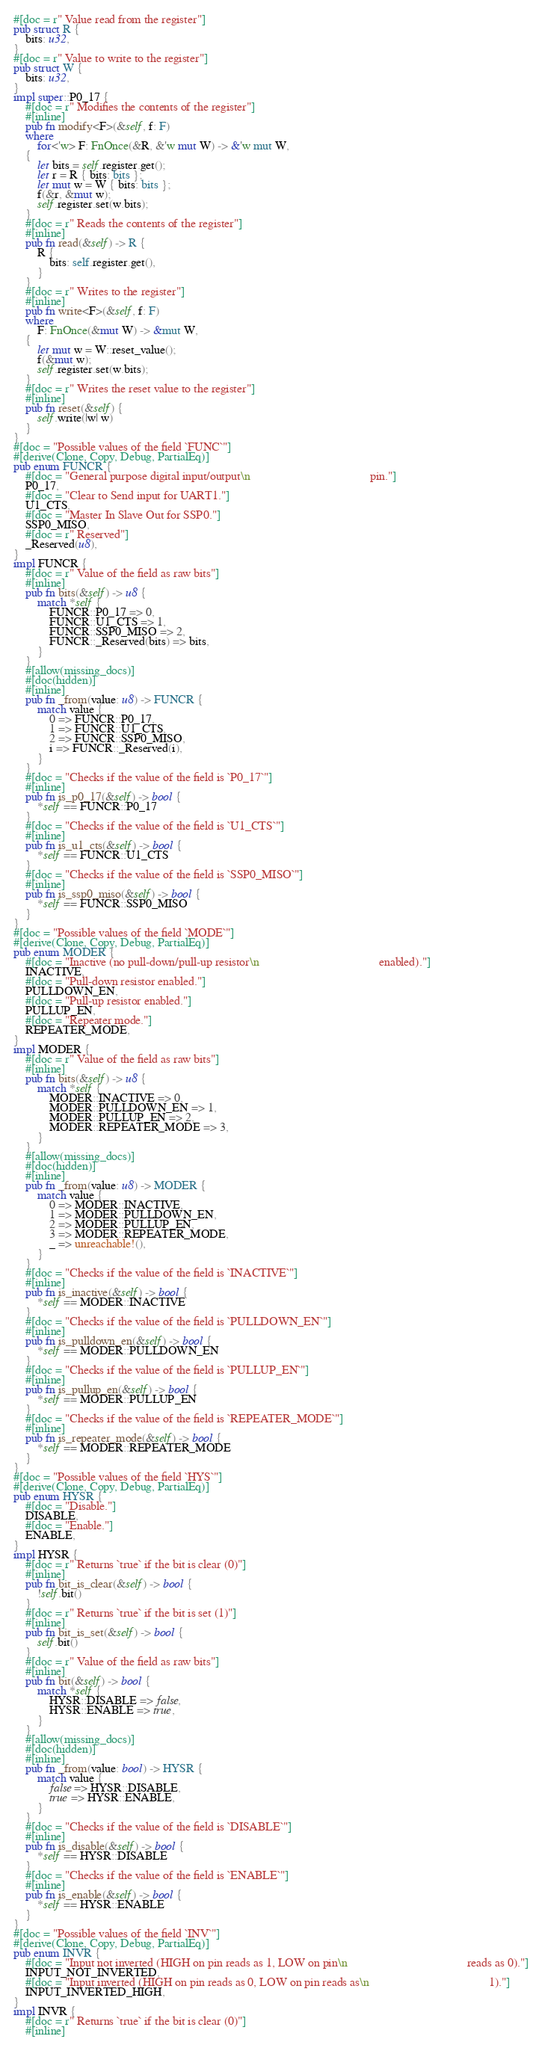<code> <loc_0><loc_0><loc_500><loc_500><_Rust_>#[doc = r" Value read from the register"]
pub struct R {
    bits: u32,
}
#[doc = r" Value to write to the register"]
pub struct W {
    bits: u32,
}
impl super::P0_17 {
    #[doc = r" Modifies the contents of the register"]
    #[inline]
    pub fn modify<F>(&self, f: F)
    where
        for<'w> F: FnOnce(&R, &'w mut W) -> &'w mut W,
    {
        let bits = self.register.get();
        let r = R { bits: bits };
        let mut w = W { bits: bits };
        f(&r, &mut w);
        self.register.set(w.bits);
    }
    #[doc = r" Reads the contents of the register"]
    #[inline]
    pub fn read(&self) -> R {
        R {
            bits: self.register.get(),
        }
    }
    #[doc = r" Writes to the register"]
    #[inline]
    pub fn write<F>(&self, f: F)
    where
        F: FnOnce(&mut W) -> &mut W,
    {
        let mut w = W::reset_value();
        f(&mut w);
        self.register.set(w.bits);
    }
    #[doc = r" Writes the reset value to the register"]
    #[inline]
    pub fn reset(&self) {
        self.write(|w| w)
    }
}
#[doc = "Possible values of the field `FUNC`"]
#[derive(Clone, Copy, Debug, PartialEq)]
pub enum FUNCR {
    #[doc = "General purpose digital input/output\n                                        pin."]
    P0_17,
    #[doc = "Clear to Send input for UART1."]
    U1_CTS,
    #[doc = "Master In Slave Out for SSP0."]
    SSP0_MISO,
    #[doc = r" Reserved"]
    _Reserved(u8),
}
impl FUNCR {
    #[doc = r" Value of the field as raw bits"]
    #[inline]
    pub fn bits(&self) -> u8 {
        match *self {
            FUNCR::P0_17 => 0,
            FUNCR::U1_CTS => 1,
            FUNCR::SSP0_MISO => 2,
            FUNCR::_Reserved(bits) => bits,
        }
    }
    #[allow(missing_docs)]
    #[doc(hidden)]
    #[inline]
    pub fn _from(value: u8) -> FUNCR {
        match value {
            0 => FUNCR::P0_17,
            1 => FUNCR::U1_CTS,
            2 => FUNCR::SSP0_MISO,
            i => FUNCR::_Reserved(i),
        }
    }
    #[doc = "Checks if the value of the field is `P0_17`"]
    #[inline]
    pub fn is_p0_17(&self) -> bool {
        *self == FUNCR::P0_17
    }
    #[doc = "Checks if the value of the field is `U1_CTS`"]
    #[inline]
    pub fn is_u1_cts(&self) -> bool {
        *self == FUNCR::U1_CTS
    }
    #[doc = "Checks if the value of the field is `SSP0_MISO`"]
    #[inline]
    pub fn is_ssp0_miso(&self) -> bool {
        *self == FUNCR::SSP0_MISO
    }
}
#[doc = "Possible values of the field `MODE`"]
#[derive(Clone, Copy, Debug, PartialEq)]
pub enum MODER {
    #[doc = "Inactive (no pull-down/pull-up resistor\n                                        enabled)."]
    INACTIVE,
    #[doc = "Pull-down resistor enabled."]
    PULLDOWN_EN,
    #[doc = "Pull-up resistor enabled."]
    PULLUP_EN,
    #[doc = "Repeater mode."]
    REPEATER_MODE,
}
impl MODER {
    #[doc = r" Value of the field as raw bits"]
    #[inline]
    pub fn bits(&self) -> u8 {
        match *self {
            MODER::INACTIVE => 0,
            MODER::PULLDOWN_EN => 1,
            MODER::PULLUP_EN => 2,
            MODER::REPEATER_MODE => 3,
        }
    }
    #[allow(missing_docs)]
    #[doc(hidden)]
    #[inline]
    pub fn _from(value: u8) -> MODER {
        match value {
            0 => MODER::INACTIVE,
            1 => MODER::PULLDOWN_EN,
            2 => MODER::PULLUP_EN,
            3 => MODER::REPEATER_MODE,
            _ => unreachable!(),
        }
    }
    #[doc = "Checks if the value of the field is `INACTIVE`"]
    #[inline]
    pub fn is_inactive(&self) -> bool {
        *self == MODER::INACTIVE
    }
    #[doc = "Checks if the value of the field is `PULLDOWN_EN`"]
    #[inline]
    pub fn is_pulldown_en(&self) -> bool {
        *self == MODER::PULLDOWN_EN
    }
    #[doc = "Checks if the value of the field is `PULLUP_EN`"]
    #[inline]
    pub fn is_pullup_en(&self) -> bool {
        *self == MODER::PULLUP_EN
    }
    #[doc = "Checks if the value of the field is `REPEATER_MODE`"]
    #[inline]
    pub fn is_repeater_mode(&self) -> bool {
        *self == MODER::REPEATER_MODE
    }
}
#[doc = "Possible values of the field `HYS`"]
#[derive(Clone, Copy, Debug, PartialEq)]
pub enum HYSR {
    #[doc = "Disable."]
    DISABLE,
    #[doc = "Enable."]
    ENABLE,
}
impl HYSR {
    #[doc = r" Returns `true` if the bit is clear (0)"]
    #[inline]
    pub fn bit_is_clear(&self) -> bool {
        !self.bit()
    }
    #[doc = r" Returns `true` if the bit is set (1)"]
    #[inline]
    pub fn bit_is_set(&self) -> bool {
        self.bit()
    }
    #[doc = r" Value of the field as raw bits"]
    #[inline]
    pub fn bit(&self) -> bool {
        match *self {
            HYSR::DISABLE => false,
            HYSR::ENABLE => true,
        }
    }
    #[allow(missing_docs)]
    #[doc(hidden)]
    #[inline]
    pub fn _from(value: bool) -> HYSR {
        match value {
            false => HYSR::DISABLE,
            true => HYSR::ENABLE,
        }
    }
    #[doc = "Checks if the value of the field is `DISABLE`"]
    #[inline]
    pub fn is_disable(&self) -> bool {
        *self == HYSR::DISABLE
    }
    #[doc = "Checks if the value of the field is `ENABLE`"]
    #[inline]
    pub fn is_enable(&self) -> bool {
        *self == HYSR::ENABLE
    }
}
#[doc = "Possible values of the field `INV`"]
#[derive(Clone, Copy, Debug, PartialEq)]
pub enum INVR {
    #[doc = "Input not inverted (HIGH on pin reads as 1, LOW on pin\n                                        reads as 0)."]
    INPUT_NOT_INVERTED,
    #[doc = "Input inverted (HIGH on pin reads as 0, LOW on pin reads as\n                                        1)."]
    INPUT_INVERTED_HIGH,
}
impl INVR {
    #[doc = r" Returns `true` if the bit is clear (0)"]
    #[inline]</code> 